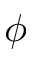<formula> <loc_0><loc_0><loc_500><loc_500>\phi</formula> 